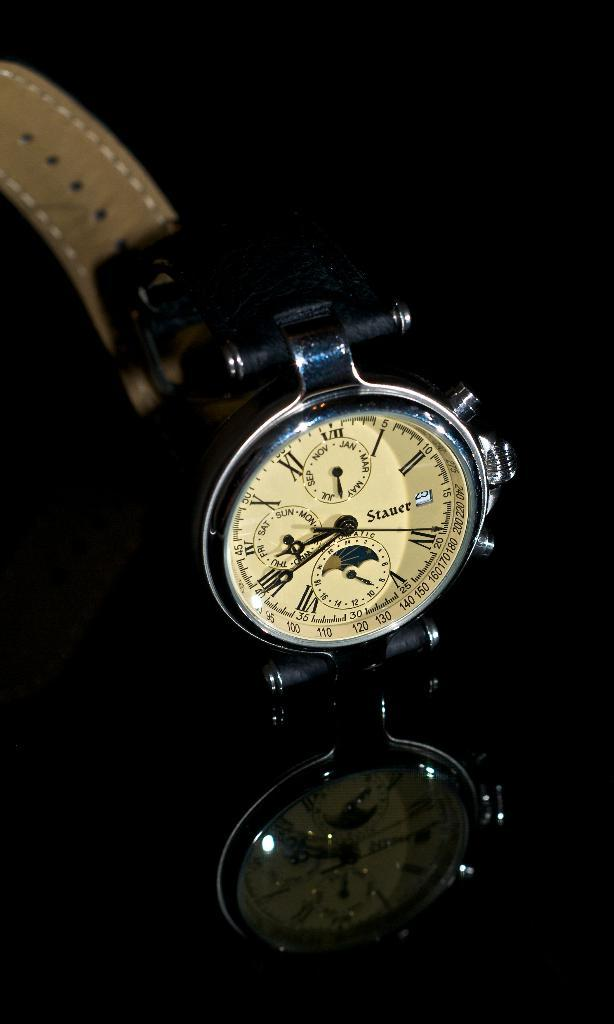<image>
Create a compact narrative representing the image presented. A watch has the brand name Stauer on the face of it. 